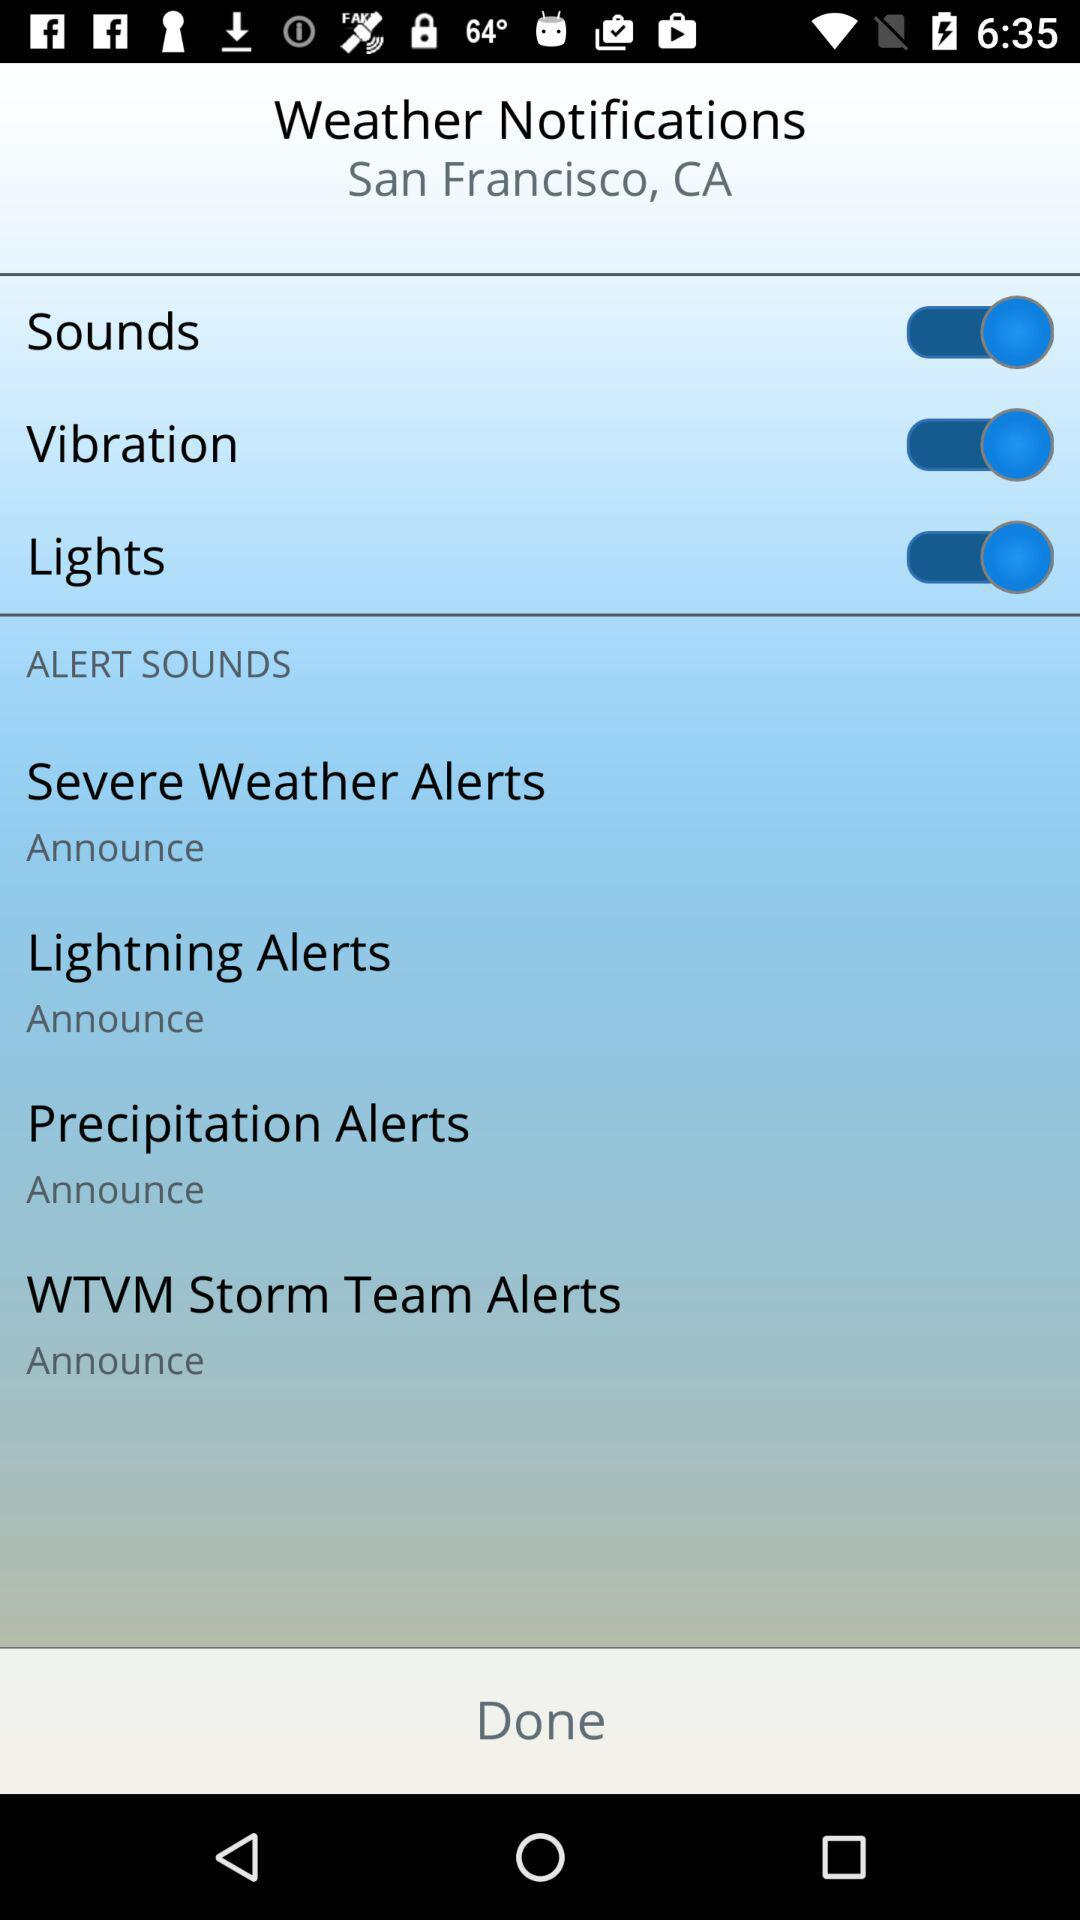How many alert types are there?
Answer the question using a single word or phrase. 4 